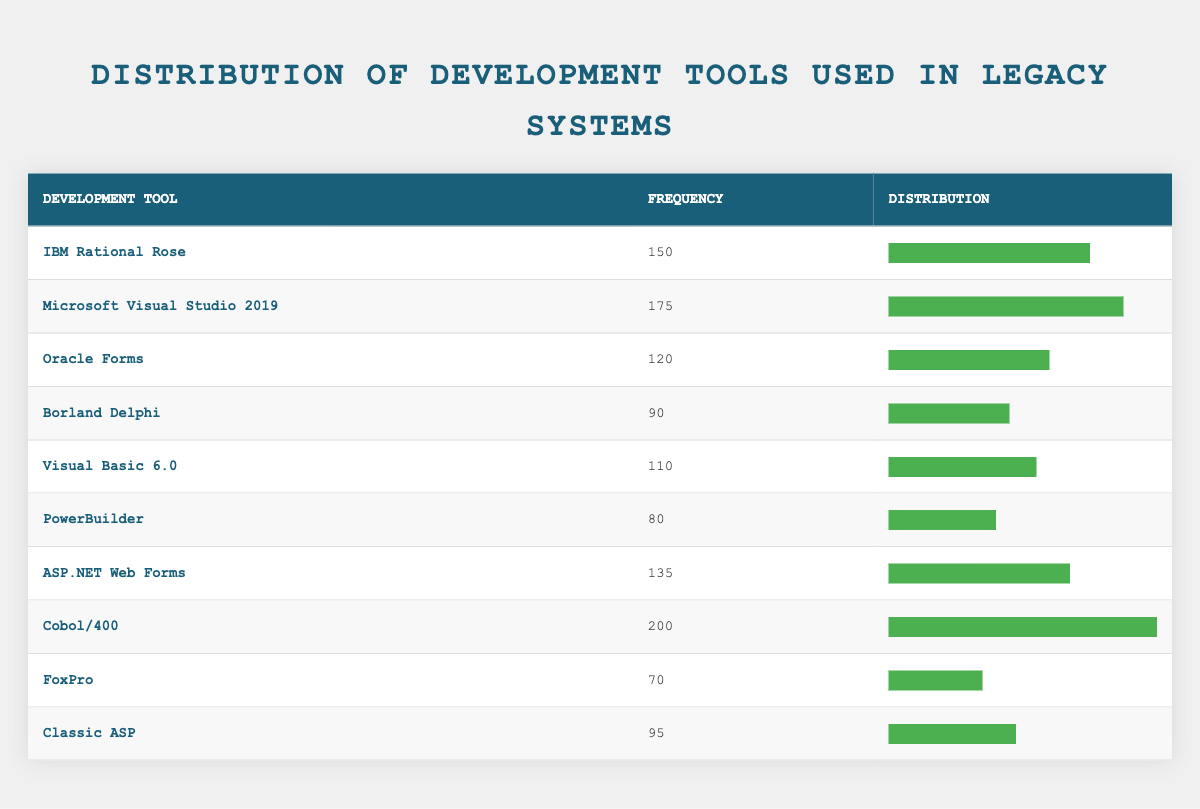What is the frequency of Cobol/400? The frequency of Cobol/400 is listed directly in the table under the "Frequency" column, which shows a value of 200.
Answer: 200 Which development tool has the highest frequency? Cobol/400 has the highest frequency of 200, which is greater than the frequencies of all other tools presented in the table.
Answer: Cobol/400 What is the average frequency of the development tools listed? To find the average frequency, add all the frequencies together: 150 + 175 + 120 + 90 + 110 + 80 + 135 + 200 + 70 + 95 = 1150. Then, divide by the number of tools, which is 10. So, 1150 / 10 = 115.
Answer: 115 Is Microsoft Visual Studio 2019 used more frequently than Oracle Forms? Yes, Microsoft Visual Studio 2019 has a frequency of 175, which is greater than Oracle Forms' frequency of 120, indicating that it is used more frequently.
Answer: Yes How many tools have a frequency of over 100? By checking the frequencies, the tools with frequencies over 100 are: IBM Rational Rose (150), Microsoft Visual Studio 2019 (175), ASP.NET Web Forms (135), and Cobol/400 (200). This totals 4 tools.
Answer: 4 What is the difference in frequency between the most used tool and the least used tool? The most used tool is Cobol/400 with a frequency of 200, and the least used tool is FoxPro with a frequency of 70. The difference is calculated as 200 - 70 = 130.
Answer: 130 Are there more tools with a frequency of less than 100 or more than 100? There are 4 tools with a frequency of less than 100 (Borland Delphi, PowerBuilder, FoxPro, Classic ASP) and 6 tools with a frequency of more than 100. Therefore, there are more tools with a frequency of over 100.
Answer: More than 100 What is the frequency distribution for Visual Basic 6.0 and PowerBuilder combined? The frequency of Visual Basic 6.0 is 110 and for PowerBuilder, it is 80. Adding these two gives 110 + 80 = 190, representing their combined frequency.
Answer: 190 Which tool has a frequency closest to 100? The frequencies closest to 100 are Visual Basic 6.0 with a frequency of 110 and Classic ASP with a frequency of 95. The closest is Classic ASP because it is only 5 units away.
Answer: Classic ASP 